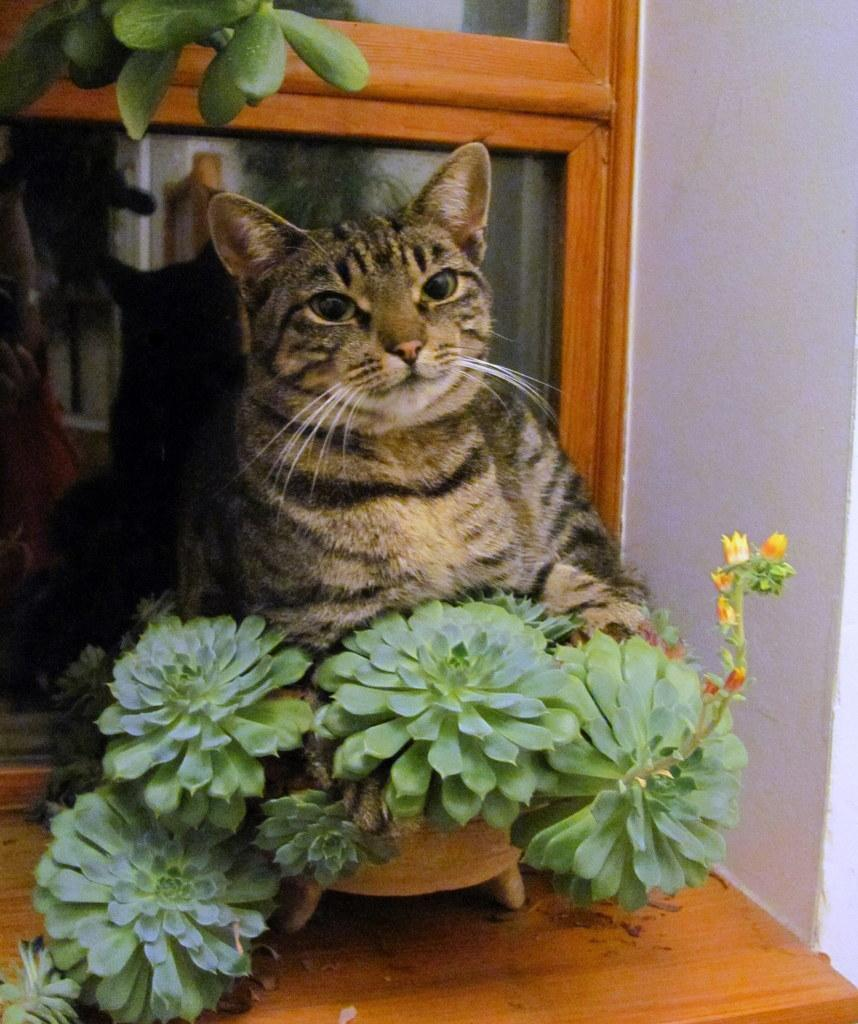What piece of furniture is present in the image? There is a table in the image. What is placed on the table? A flower pot is placed on the table. What type of animal is in the image? There is a cat in the image. Where is the cat located in relation to the flower pot? The cat is beside the flower pot. What type of door is visible in the image? There is a glass door in the image. Where is the glass door located in relation to the cat? The glass door is behind the cat. What color is the wall on the right side of the image? The wall on the right side of the image is white. What type of vase is the cat using to point at the flower pot? There is no vase present in the image, and the cat is not using any object to point at the flower pot. 